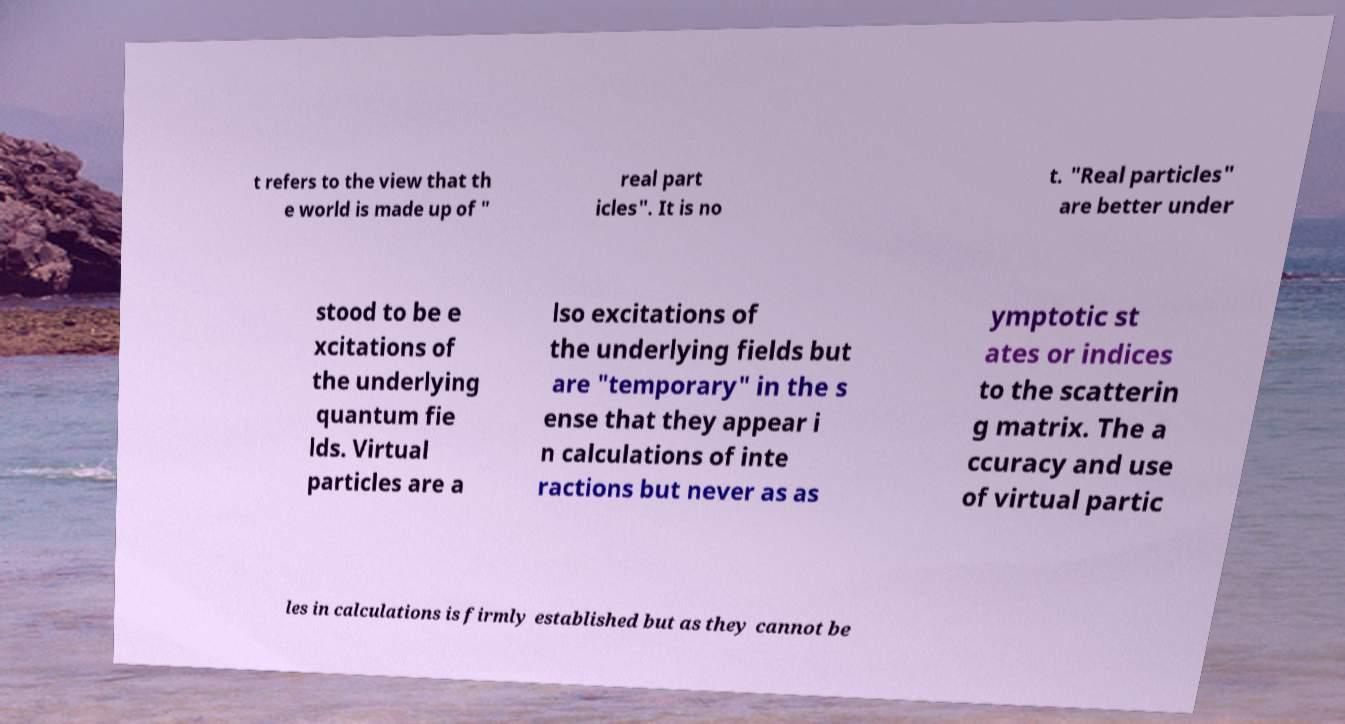Could you assist in decoding the text presented in this image and type it out clearly? t refers to the view that th e world is made up of " real part icles". It is no t. "Real particles" are better under stood to be e xcitations of the underlying quantum fie lds. Virtual particles are a lso excitations of the underlying fields but are "temporary" in the s ense that they appear i n calculations of inte ractions but never as as ymptotic st ates or indices to the scatterin g matrix. The a ccuracy and use of virtual partic les in calculations is firmly established but as they cannot be 